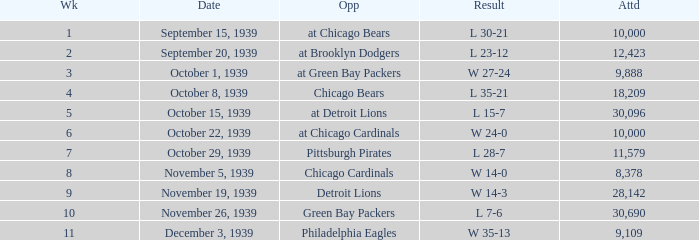Which Attendance has an Opponent of green bay packers, and a Week larger than 10? None. 